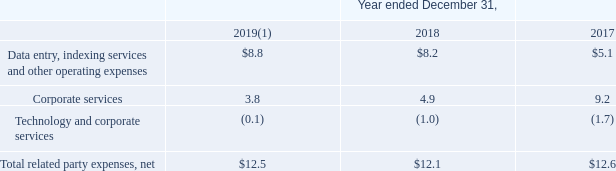Consolidated Statements of Earnings and Comprehensive Earnings
A detail of related party items included in Operating expenses (net of expense reimbursements) is as follows (in millions):
(1) Transactions with FNF are summarized through November 30, 2019, the date after which FNF is no longer considered a related party.
What was the date after which FNF was no longer considered a related party? November 30, 2019. What was the amount of Corporate Services in 2018?
Answer scale should be: million. 4.9. Which years does the table provide information for related party items included in Operating expenses (net of expense reimbursements)? 2019, 2018, 2017. What was the change in corporate services between 2017 and 2018?
Answer scale should be: million. 4.9-9.2
Answer: -4.3. What was the change in Total related party expenses, net between 2018 and 2019?
Answer scale should be: million. 12.5-12.1
Answer: 0.4. What was the percentage change in Technology and corporate services between 2017 and 2018?
Answer scale should be: percent. (-1.0-(-1.7))/-1.7
Answer: -41.18. 